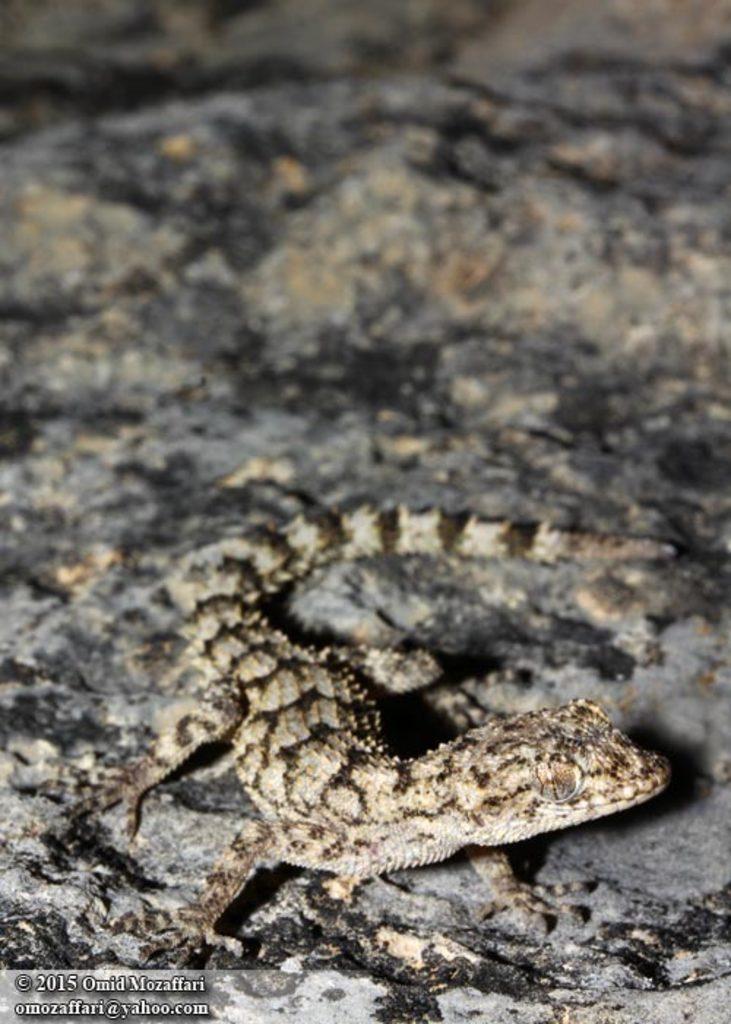How would you summarize this image in a sentence or two? In this image in the center there is a lizard, and at the bottom there is a walkway. 